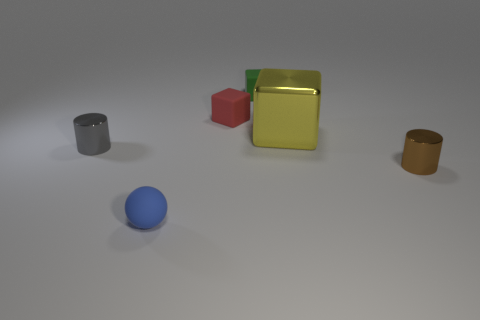Subtract all balls. How many objects are left? 5 Add 1 small green metallic spheres. How many objects exist? 7 Subtract all large green metal things. Subtract all small cylinders. How many objects are left? 4 Add 3 small red objects. How many small red objects are left? 4 Add 6 small brown rubber balls. How many small brown rubber balls exist? 6 Subtract 0 brown blocks. How many objects are left? 6 